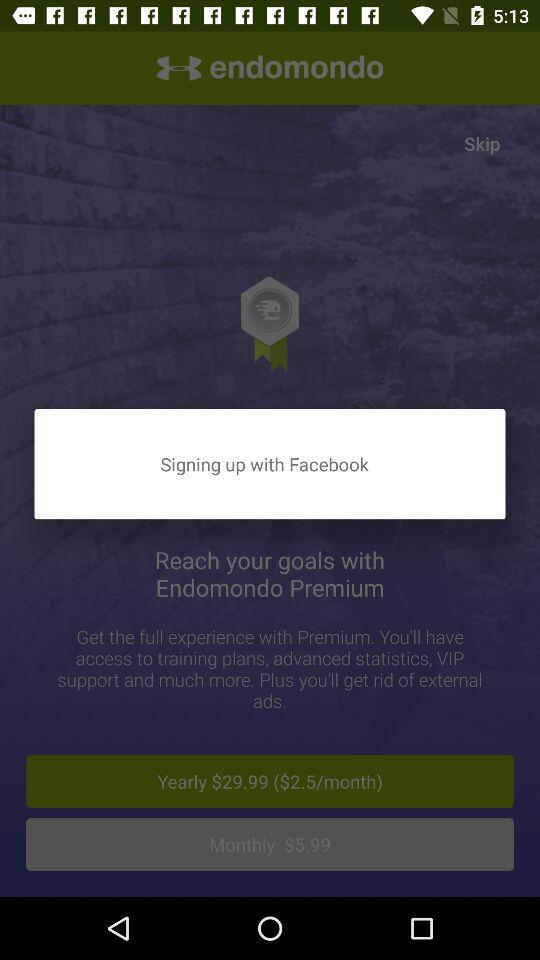What is the monthly cost of the premium? The monthly cost of the premium is $5.99. 